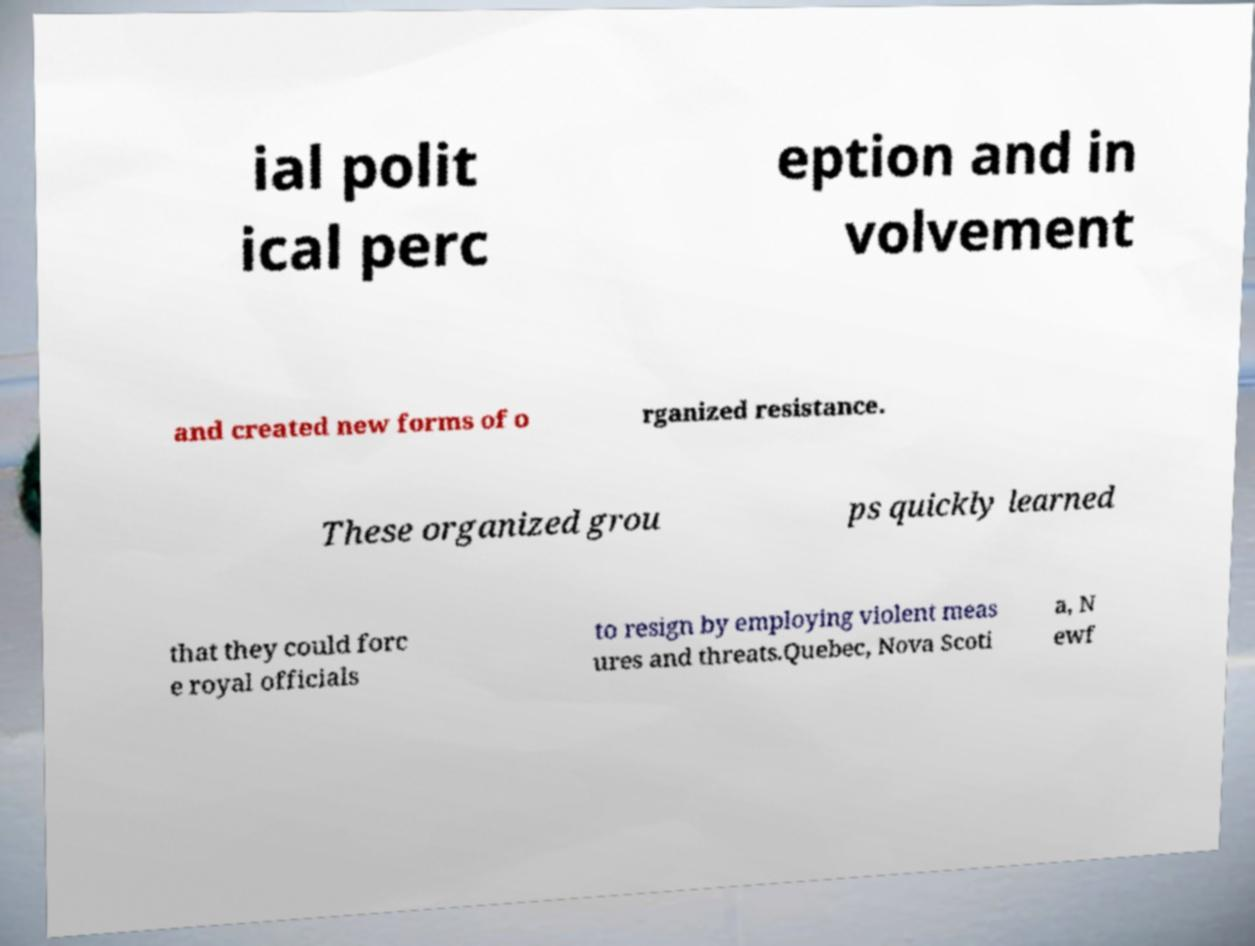I need the written content from this picture converted into text. Can you do that? ial polit ical perc eption and in volvement and created new forms of o rganized resistance. These organized grou ps quickly learned that they could forc e royal officials to resign by employing violent meas ures and threats.Quebec, Nova Scoti a, N ewf 